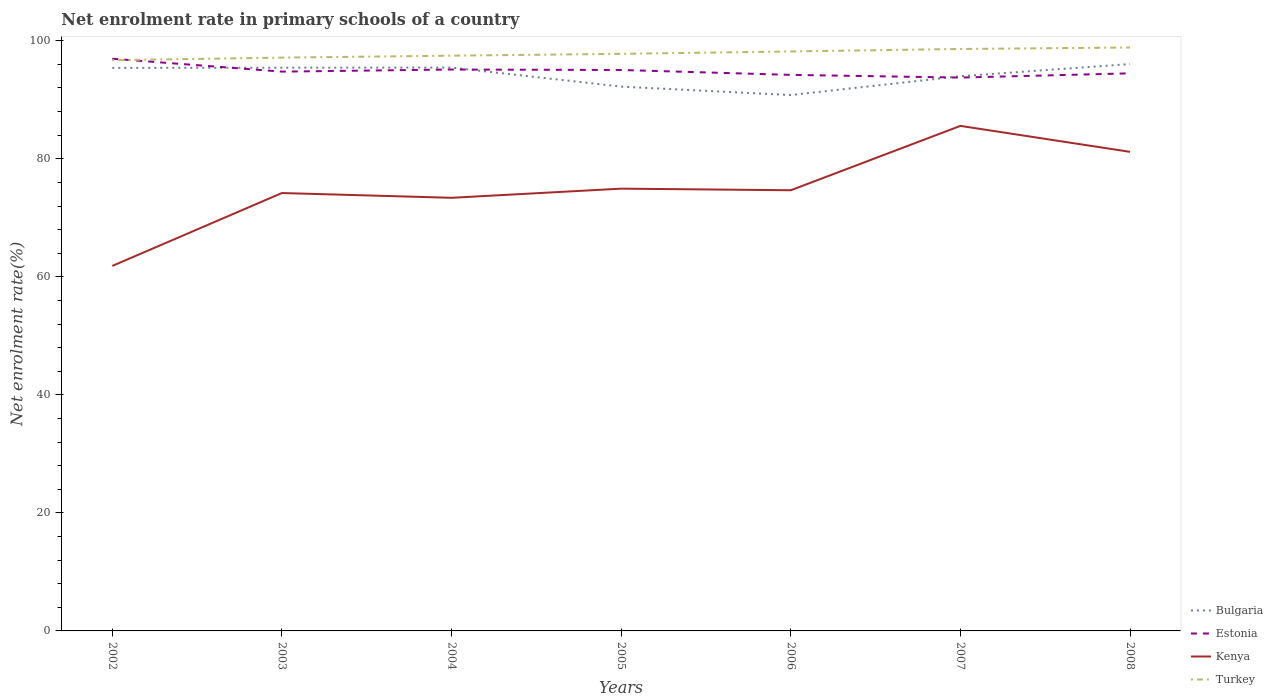How many different coloured lines are there?
Your answer should be compact. 4. Does the line corresponding to Kenya intersect with the line corresponding to Estonia?
Your response must be concise. No. Across all years, what is the maximum net enrolment rate in primary schools in Estonia?
Your response must be concise. 93.77. In which year was the net enrolment rate in primary schools in Kenya maximum?
Offer a very short reply. 2002. What is the total net enrolment rate in primary schools in Bulgaria in the graph?
Give a very brief answer. 1.41. What is the difference between the highest and the second highest net enrolment rate in primary schools in Kenya?
Your answer should be compact. 23.73. Is the net enrolment rate in primary schools in Bulgaria strictly greater than the net enrolment rate in primary schools in Estonia over the years?
Make the answer very short. No. How many lines are there?
Make the answer very short. 4. What is the difference between two consecutive major ticks on the Y-axis?
Provide a succinct answer. 20. Does the graph contain any zero values?
Make the answer very short. No. What is the title of the graph?
Your response must be concise. Net enrolment rate in primary schools of a country. Does "Virgin Islands" appear as one of the legend labels in the graph?
Give a very brief answer. No. What is the label or title of the Y-axis?
Keep it short and to the point. Net enrolment rate(%). What is the Net enrolment rate(%) of Bulgaria in 2002?
Your answer should be compact. 95.41. What is the Net enrolment rate(%) of Estonia in 2002?
Offer a terse response. 96.96. What is the Net enrolment rate(%) in Kenya in 2002?
Your answer should be very brief. 61.85. What is the Net enrolment rate(%) of Turkey in 2002?
Keep it short and to the point. 96.71. What is the Net enrolment rate(%) in Bulgaria in 2003?
Your response must be concise. 95.44. What is the Net enrolment rate(%) of Estonia in 2003?
Give a very brief answer. 94.77. What is the Net enrolment rate(%) of Kenya in 2003?
Offer a very short reply. 74.2. What is the Net enrolment rate(%) of Turkey in 2003?
Offer a terse response. 97.15. What is the Net enrolment rate(%) of Bulgaria in 2004?
Provide a succinct answer. 95.46. What is the Net enrolment rate(%) in Estonia in 2004?
Ensure brevity in your answer.  95.13. What is the Net enrolment rate(%) of Kenya in 2004?
Provide a succinct answer. 73.39. What is the Net enrolment rate(%) in Turkey in 2004?
Your answer should be very brief. 97.48. What is the Net enrolment rate(%) in Bulgaria in 2005?
Offer a terse response. 92.23. What is the Net enrolment rate(%) in Estonia in 2005?
Your answer should be very brief. 95.05. What is the Net enrolment rate(%) in Kenya in 2005?
Provide a short and direct response. 74.94. What is the Net enrolment rate(%) in Turkey in 2005?
Provide a short and direct response. 97.79. What is the Net enrolment rate(%) in Bulgaria in 2006?
Provide a short and direct response. 90.8. What is the Net enrolment rate(%) in Estonia in 2006?
Keep it short and to the point. 94.22. What is the Net enrolment rate(%) of Kenya in 2006?
Keep it short and to the point. 74.67. What is the Net enrolment rate(%) in Turkey in 2006?
Offer a terse response. 98.19. What is the Net enrolment rate(%) in Bulgaria in 2007?
Make the answer very short. 94. What is the Net enrolment rate(%) in Estonia in 2007?
Your answer should be very brief. 93.77. What is the Net enrolment rate(%) of Kenya in 2007?
Your answer should be compact. 85.58. What is the Net enrolment rate(%) in Turkey in 2007?
Ensure brevity in your answer.  98.61. What is the Net enrolment rate(%) of Bulgaria in 2008?
Provide a short and direct response. 96.05. What is the Net enrolment rate(%) in Estonia in 2008?
Your answer should be compact. 94.48. What is the Net enrolment rate(%) in Kenya in 2008?
Offer a very short reply. 81.18. What is the Net enrolment rate(%) in Turkey in 2008?
Make the answer very short. 98.86. Across all years, what is the maximum Net enrolment rate(%) of Bulgaria?
Provide a succinct answer. 96.05. Across all years, what is the maximum Net enrolment rate(%) of Estonia?
Your answer should be very brief. 96.96. Across all years, what is the maximum Net enrolment rate(%) in Kenya?
Make the answer very short. 85.58. Across all years, what is the maximum Net enrolment rate(%) in Turkey?
Your response must be concise. 98.86. Across all years, what is the minimum Net enrolment rate(%) in Bulgaria?
Provide a short and direct response. 90.8. Across all years, what is the minimum Net enrolment rate(%) of Estonia?
Your answer should be compact. 93.77. Across all years, what is the minimum Net enrolment rate(%) of Kenya?
Offer a very short reply. 61.85. Across all years, what is the minimum Net enrolment rate(%) of Turkey?
Provide a succinct answer. 96.71. What is the total Net enrolment rate(%) in Bulgaria in the graph?
Ensure brevity in your answer.  659.4. What is the total Net enrolment rate(%) of Estonia in the graph?
Your response must be concise. 664.39. What is the total Net enrolment rate(%) of Kenya in the graph?
Your answer should be compact. 525.82. What is the total Net enrolment rate(%) of Turkey in the graph?
Your response must be concise. 684.78. What is the difference between the Net enrolment rate(%) in Bulgaria in 2002 and that in 2003?
Offer a terse response. -0.03. What is the difference between the Net enrolment rate(%) in Estonia in 2002 and that in 2003?
Keep it short and to the point. 2.18. What is the difference between the Net enrolment rate(%) of Kenya in 2002 and that in 2003?
Keep it short and to the point. -12.35. What is the difference between the Net enrolment rate(%) of Turkey in 2002 and that in 2003?
Offer a terse response. -0.44. What is the difference between the Net enrolment rate(%) in Bulgaria in 2002 and that in 2004?
Provide a succinct answer. -0.06. What is the difference between the Net enrolment rate(%) of Estonia in 2002 and that in 2004?
Offer a very short reply. 1.83. What is the difference between the Net enrolment rate(%) in Kenya in 2002 and that in 2004?
Your answer should be compact. -11.54. What is the difference between the Net enrolment rate(%) in Turkey in 2002 and that in 2004?
Your answer should be very brief. -0.77. What is the difference between the Net enrolment rate(%) in Bulgaria in 2002 and that in 2005?
Offer a terse response. 3.18. What is the difference between the Net enrolment rate(%) of Estonia in 2002 and that in 2005?
Your answer should be compact. 1.91. What is the difference between the Net enrolment rate(%) of Kenya in 2002 and that in 2005?
Your answer should be very brief. -13.1. What is the difference between the Net enrolment rate(%) of Turkey in 2002 and that in 2005?
Offer a very short reply. -1.08. What is the difference between the Net enrolment rate(%) of Bulgaria in 2002 and that in 2006?
Provide a short and direct response. 4.6. What is the difference between the Net enrolment rate(%) in Estonia in 2002 and that in 2006?
Ensure brevity in your answer.  2.74. What is the difference between the Net enrolment rate(%) in Kenya in 2002 and that in 2006?
Ensure brevity in your answer.  -12.82. What is the difference between the Net enrolment rate(%) of Turkey in 2002 and that in 2006?
Your answer should be compact. -1.48. What is the difference between the Net enrolment rate(%) of Bulgaria in 2002 and that in 2007?
Give a very brief answer. 1.41. What is the difference between the Net enrolment rate(%) in Estonia in 2002 and that in 2007?
Give a very brief answer. 3.19. What is the difference between the Net enrolment rate(%) of Kenya in 2002 and that in 2007?
Give a very brief answer. -23.73. What is the difference between the Net enrolment rate(%) in Turkey in 2002 and that in 2007?
Ensure brevity in your answer.  -1.9. What is the difference between the Net enrolment rate(%) in Bulgaria in 2002 and that in 2008?
Keep it short and to the point. -0.65. What is the difference between the Net enrolment rate(%) of Estonia in 2002 and that in 2008?
Keep it short and to the point. 2.47. What is the difference between the Net enrolment rate(%) of Kenya in 2002 and that in 2008?
Offer a very short reply. -19.33. What is the difference between the Net enrolment rate(%) of Turkey in 2002 and that in 2008?
Give a very brief answer. -2.15. What is the difference between the Net enrolment rate(%) in Bulgaria in 2003 and that in 2004?
Keep it short and to the point. -0.03. What is the difference between the Net enrolment rate(%) in Estonia in 2003 and that in 2004?
Your answer should be very brief. -0.36. What is the difference between the Net enrolment rate(%) of Kenya in 2003 and that in 2004?
Your answer should be compact. 0.81. What is the difference between the Net enrolment rate(%) in Turkey in 2003 and that in 2004?
Offer a very short reply. -0.33. What is the difference between the Net enrolment rate(%) in Bulgaria in 2003 and that in 2005?
Offer a very short reply. 3.21. What is the difference between the Net enrolment rate(%) of Estonia in 2003 and that in 2005?
Give a very brief answer. -0.28. What is the difference between the Net enrolment rate(%) in Kenya in 2003 and that in 2005?
Offer a very short reply. -0.74. What is the difference between the Net enrolment rate(%) in Turkey in 2003 and that in 2005?
Your response must be concise. -0.64. What is the difference between the Net enrolment rate(%) in Bulgaria in 2003 and that in 2006?
Offer a terse response. 4.63. What is the difference between the Net enrolment rate(%) of Estonia in 2003 and that in 2006?
Your response must be concise. 0.55. What is the difference between the Net enrolment rate(%) of Kenya in 2003 and that in 2006?
Give a very brief answer. -0.47. What is the difference between the Net enrolment rate(%) of Turkey in 2003 and that in 2006?
Your response must be concise. -1.04. What is the difference between the Net enrolment rate(%) in Bulgaria in 2003 and that in 2007?
Your answer should be compact. 1.44. What is the difference between the Net enrolment rate(%) in Estonia in 2003 and that in 2007?
Your response must be concise. 1.01. What is the difference between the Net enrolment rate(%) of Kenya in 2003 and that in 2007?
Keep it short and to the point. -11.38. What is the difference between the Net enrolment rate(%) of Turkey in 2003 and that in 2007?
Make the answer very short. -1.46. What is the difference between the Net enrolment rate(%) in Bulgaria in 2003 and that in 2008?
Keep it short and to the point. -0.62. What is the difference between the Net enrolment rate(%) of Estonia in 2003 and that in 2008?
Offer a terse response. 0.29. What is the difference between the Net enrolment rate(%) in Kenya in 2003 and that in 2008?
Provide a succinct answer. -6.98. What is the difference between the Net enrolment rate(%) of Turkey in 2003 and that in 2008?
Give a very brief answer. -1.71. What is the difference between the Net enrolment rate(%) of Bulgaria in 2004 and that in 2005?
Provide a short and direct response. 3.23. What is the difference between the Net enrolment rate(%) of Estonia in 2004 and that in 2005?
Provide a succinct answer. 0.08. What is the difference between the Net enrolment rate(%) in Kenya in 2004 and that in 2005?
Your answer should be compact. -1.55. What is the difference between the Net enrolment rate(%) of Turkey in 2004 and that in 2005?
Provide a succinct answer. -0.31. What is the difference between the Net enrolment rate(%) in Bulgaria in 2004 and that in 2006?
Your response must be concise. 4.66. What is the difference between the Net enrolment rate(%) in Estonia in 2004 and that in 2006?
Your response must be concise. 0.91. What is the difference between the Net enrolment rate(%) in Kenya in 2004 and that in 2006?
Offer a terse response. -1.28. What is the difference between the Net enrolment rate(%) in Turkey in 2004 and that in 2006?
Keep it short and to the point. -0.72. What is the difference between the Net enrolment rate(%) of Bulgaria in 2004 and that in 2007?
Provide a succinct answer. 1.47. What is the difference between the Net enrolment rate(%) in Estonia in 2004 and that in 2007?
Your answer should be very brief. 1.36. What is the difference between the Net enrolment rate(%) of Kenya in 2004 and that in 2007?
Make the answer very short. -12.19. What is the difference between the Net enrolment rate(%) of Turkey in 2004 and that in 2007?
Your response must be concise. -1.14. What is the difference between the Net enrolment rate(%) of Bulgaria in 2004 and that in 2008?
Keep it short and to the point. -0.59. What is the difference between the Net enrolment rate(%) of Estonia in 2004 and that in 2008?
Provide a succinct answer. 0.65. What is the difference between the Net enrolment rate(%) in Kenya in 2004 and that in 2008?
Keep it short and to the point. -7.79. What is the difference between the Net enrolment rate(%) in Turkey in 2004 and that in 2008?
Keep it short and to the point. -1.39. What is the difference between the Net enrolment rate(%) of Bulgaria in 2005 and that in 2006?
Provide a short and direct response. 1.43. What is the difference between the Net enrolment rate(%) of Estonia in 2005 and that in 2006?
Ensure brevity in your answer.  0.83. What is the difference between the Net enrolment rate(%) in Kenya in 2005 and that in 2006?
Make the answer very short. 0.27. What is the difference between the Net enrolment rate(%) of Turkey in 2005 and that in 2006?
Ensure brevity in your answer.  -0.4. What is the difference between the Net enrolment rate(%) of Bulgaria in 2005 and that in 2007?
Provide a succinct answer. -1.77. What is the difference between the Net enrolment rate(%) in Estonia in 2005 and that in 2007?
Provide a short and direct response. 1.29. What is the difference between the Net enrolment rate(%) in Kenya in 2005 and that in 2007?
Ensure brevity in your answer.  -10.63. What is the difference between the Net enrolment rate(%) of Turkey in 2005 and that in 2007?
Offer a terse response. -0.82. What is the difference between the Net enrolment rate(%) of Bulgaria in 2005 and that in 2008?
Offer a terse response. -3.83. What is the difference between the Net enrolment rate(%) of Estonia in 2005 and that in 2008?
Your answer should be compact. 0.57. What is the difference between the Net enrolment rate(%) of Kenya in 2005 and that in 2008?
Your answer should be compact. -6.24. What is the difference between the Net enrolment rate(%) of Turkey in 2005 and that in 2008?
Your answer should be compact. -1.07. What is the difference between the Net enrolment rate(%) in Bulgaria in 2006 and that in 2007?
Your response must be concise. -3.19. What is the difference between the Net enrolment rate(%) of Estonia in 2006 and that in 2007?
Provide a succinct answer. 0.46. What is the difference between the Net enrolment rate(%) in Kenya in 2006 and that in 2007?
Provide a short and direct response. -10.91. What is the difference between the Net enrolment rate(%) of Turkey in 2006 and that in 2007?
Give a very brief answer. -0.42. What is the difference between the Net enrolment rate(%) of Bulgaria in 2006 and that in 2008?
Make the answer very short. -5.25. What is the difference between the Net enrolment rate(%) of Estonia in 2006 and that in 2008?
Your answer should be compact. -0.26. What is the difference between the Net enrolment rate(%) of Kenya in 2006 and that in 2008?
Offer a terse response. -6.51. What is the difference between the Net enrolment rate(%) of Turkey in 2006 and that in 2008?
Your response must be concise. -0.67. What is the difference between the Net enrolment rate(%) of Bulgaria in 2007 and that in 2008?
Provide a succinct answer. -2.06. What is the difference between the Net enrolment rate(%) of Estonia in 2007 and that in 2008?
Ensure brevity in your answer.  -0.72. What is the difference between the Net enrolment rate(%) of Kenya in 2007 and that in 2008?
Your answer should be very brief. 4.4. What is the difference between the Net enrolment rate(%) in Turkey in 2007 and that in 2008?
Give a very brief answer. -0.25. What is the difference between the Net enrolment rate(%) in Bulgaria in 2002 and the Net enrolment rate(%) in Estonia in 2003?
Give a very brief answer. 0.63. What is the difference between the Net enrolment rate(%) of Bulgaria in 2002 and the Net enrolment rate(%) of Kenya in 2003?
Your answer should be very brief. 21.21. What is the difference between the Net enrolment rate(%) of Bulgaria in 2002 and the Net enrolment rate(%) of Turkey in 2003?
Give a very brief answer. -1.74. What is the difference between the Net enrolment rate(%) in Estonia in 2002 and the Net enrolment rate(%) in Kenya in 2003?
Ensure brevity in your answer.  22.76. What is the difference between the Net enrolment rate(%) of Estonia in 2002 and the Net enrolment rate(%) of Turkey in 2003?
Keep it short and to the point. -0.19. What is the difference between the Net enrolment rate(%) in Kenya in 2002 and the Net enrolment rate(%) in Turkey in 2003?
Your answer should be compact. -35.3. What is the difference between the Net enrolment rate(%) of Bulgaria in 2002 and the Net enrolment rate(%) of Estonia in 2004?
Your answer should be compact. 0.28. What is the difference between the Net enrolment rate(%) of Bulgaria in 2002 and the Net enrolment rate(%) of Kenya in 2004?
Your answer should be very brief. 22.02. What is the difference between the Net enrolment rate(%) in Bulgaria in 2002 and the Net enrolment rate(%) in Turkey in 2004?
Your answer should be very brief. -2.07. What is the difference between the Net enrolment rate(%) in Estonia in 2002 and the Net enrolment rate(%) in Kenya in 2004?
Your response must be concise. 23.57. What is the difference between the Net enrolment rate(%) in Estonia in 2002 and the Net enrolment rate(%) in Turkey in 2004?
Your answer should be very brief. -0.52. What is the difference between the Net enrolment rate(%) in Kenya in 2002 and the Net enrolment rate(%) in Turkey in 2004?
Offer a terse response. -35.63. What is the difference between the Net enrolment rate(%) in Bulgaria in 2002 and the Net enrolment rate(%) in Estonia in 2005?
Provide a succinct answer. 0.36. What is the difference between the Net enrolment rate(%) in Bulgaria in 2002 and the Net enrolment rate(%) in Kenya in 2005?
Provide a short and direct response. 20.46. What is the difference between the Net enrolment rate(%) in Bulgaria in 2002 and the Net enrolment rate(%) in Turkey in 2005?
Ensure brevity in your answer.  -2.38. What is the difference between the Net enrolment rate(%) in Estonia in 2002 and the Net enrolment rate(%) in Kenya in 2005?
Make the answer very short. 22.01. What is the difference between the Net enrolment rate(%) in Estonia in 2002 and the Net enrolment rate(%) in Turkey in 2005?
Your answer should be compact. -0.83. What is the difference between the Net enrolment rate(%) in Kenya in 2002 and the Net enrolment rate(%) in Turkey in 2005?
Your answer should be compact. -35.94. What is the difference between the Net enrolment rate(%) in Bulgaria in 2002 and the Net enrolment rate(%) in Estonia in 2006?
Provide a succinct answer. 1.19. What is the difference between the Net enrolment rate(%) in Bulgaria in 2002 and the Net enrolment rate(%) in Kenya in 2006?
Offer a very short reply. 20.74. What is the difference between the Net enrolment rate(%) in Bulgaria in 2002 and the Net enrolment rate(%) in Turkey in 2006?
Keep it short and to the point. -2.78. What is the difference between the Net enrolment rate(%) of Estonia in 2002 and the Net enrolment rate(%) of Kenya in 2006?
Make the answer very short. 22.29. What is the difference between the Net enrolment rate(%) of Estonia in 2002 and the Net enrolment rate(%) of Turkey in 2006?
Ensure brevity in your answer.  -1.23. What is the difference between the Net enrolment rate(%) of Kenya in 2002 and the Net enrolment rate(%) of Turkey in 2006?
Provide a short and direct response. -36.34. What is the difference between the Net enrolment rate(%) in Bulgaria in 2002 and the Net enrolment rate(%) in Estonia in 2007?
Your response must be concise. 1.64. What is the difference between the Net enrolment rate(%) of Bulgaria in 2002 and the Net enrolment rate(%) of Kenya in 2007?
Your answer should be compact. 9.83. What is the difference between the Net enrolment rate(%) in Bulgaria in 2002 and the Net enrolment rate(%) in Turkey in 2007?
Your answer should be compact. -3.2. What is the difference between the Net enrolment rate(%) in Estonia in 2002 and the Net enrolment rate(%) in Kenya in 2007?
Your answer should be compact. 11.38. What is the difference between the Net enrolment rate(%) of Estonia in 2002 and the Net enrolment rate(%) of Turkey in 2007?
Your answer should be very brief. -1.65. What is the difference between the Net enrolment rate(%) in Kenya in 2002 and the Net enrolment rate(%) in Turkey in 2007?
Your answer should be compact. -36.76. What is the difference between the Net enrolment rate(%) in Bulgaria in 2002 and the Net enrolment rate(%) in Estonia in 2008?
Give a very brief answer. 0.92. What is the difference between the Net enrolment rate(%) of Bulgaria in 2002 and the Net enrolment rate(%) of Kenya in 2008?
Your answer should be very brief. 14.23. What is the difference between the Net enrolment rate(%) in Bulgaria in 2002 and the Net enrolment rate(%) in Turkey in 2008?
Make the answer very short. -3.45. What is the difference between the Net enrolment rate(%) of Estonia in 2002 and the Net enrolment rate(%) of Kenya in 2008?
Your answer should be compact. 15.78. What is the difference between the Net enrolment rate(%) in Estonia in 2002 and the Net enrolment rate(%) in Turkey in 2008?
Give a very brief answer. -1.9. What is the difference between the Net enrolment rate(%) of Kenya in 2002 and the Net enrolment rate(%) of Turkey in 2008?
Your response must be concise. -37.01. What is the difference between the Net enrolment rate(%) of Bulgaria in 2003 and the Net enrolment rate(%) of Estonia in 2004?
Ensure brevity in your answer.  0.31. What is the difference between the Net enrolment rate(%) of Bulgaria in 2003 and the Net enrolment rate(%) of Kenya in 2004?
Your response must be concise. 22.05. What is the difference between the Net enrolment rate(%) of Bulgaria in 2003 and the Net enrolment rate(%) of Turkey in 2004?
Your response must be concise. -2.04. What is the difference between the Net enrolment rate(%) in Estonia in 2003 and the Net enrolment rate(%) in Kenya in 2004?
Ensure brevity in your answer.  21.38. What is the difference between the Net enrolment rate(%) in Estonia in 2003 and the Net enrolment rate(%) in Turkey in 2004?
Your answer should be very brief. -2.7. What is the difference between the Net enrolment rate(%) in Kenya in 2003 and the Net enrolment rate(%) in Turkey in 2004?
Make the answer very short. -23.27. What is the difference between the Net enrolment rate(%) of Bulgaria in 2003 and the Net enrolment rate(%) of Estonia in 2005?
Give a very brief answer. 0.39. What is the difference between the Net enrolment rate(%) of Bulgaria in 2003 and the Net enrolment rate(%) of Kenya in 2005?
Make the answer very short. 20.49. What is the difference between the Net enrolment rate(%) of Bulgaria in 2003 and the Net enrolment rate(%) of Turkey in 2005?
Your response must be concise. -2.35. What is the difference between the Net enrolment rate(%) in Estonia in 2003 and the Net enrolment rate(%) in Kenya in 2005?
Give a very brief answer. 19.83. What is the difference between the Net enrolment rate(%) in Estonia in 2003 and the Net enrolment rate(%) in Turkey in 2005?
Provide a short and direct response. -3.01. What is the difference between the Net enrolment rate(%) in Kenya in 2003 and the Net enrolment rate(%) in Turkey in 2005?
Make the answer very short. -23.59. What is the difference between the Net enrolment rate(%) in Bulgaria in 2003 and the Net enrolment rate(%) in Estonia in 2006?
Keep it short and to the point. 1.22. What is the difference between the Net enrolment rate(%) of Bulgaria in 2003 and the Net enrolment rate(%) of Kenya in 2006?
Provide a short and direct response. 20.77. What is the difference between the Net enrolment rate(%) in Bulgaria in 2003 and the Net enrolment rate(%) in Turkey in 2006?
Your answer should be compact. -2.75. What is the difference between the Net enrolment rate(%) of Estonia in 2003 and the Net enrolment rate(%) of Kenya in 2006?
Provide a short and direct response. 20.1. What is the difference between the Net enrolment rate(%) in Estonia in 2003 and the Net enrolment rate(%) in Turkey in 2006?
Ensure brevity in your answer.  -3.42. What is the difference between the Net enrolment rate(%) of Kenya in 2003 and the Net enrolment rate(%) of Turkey in 2006?
Give a very brief answer. -23.99. What is the difference between the Net enrolment rate(%) in Bulgaria in 2003 and the Net enrolment rate(%) in Estonia in 2007?
Keep it short and to the point. 1.67. What is the difference between the Net enrolment rate(%) in Bulgaria in 2003 and the Net enrolment rate(%) in Kenya in 2007?
Provide a succinct answer. 9.86. What is the difference between the Net enrolment rate(%) in Bulgaria in 2003 and the Net enrolment rate(%) in Turkey in 2007?
Your answer should be compact. -3.17. What is the difference between the Net enrolment rate(%) in Estonia in 2003 and the Net enrolment rate(%) in Kenya in 2007?
Provide a short and direct response. 9.2. What is the difference between the Net enrolment rate(%) in Estonia in 2003 and the Net enrolment rate(%) in Turkey in 2007?
Make the answer very short. -3.84. What is the difference between the Net enrolment rate(%) in Kenya in 2003 and the Net enrolment rate(%) in Turkey in 2007?
Provide a succinct answer. -24.41. What is the difference between the Net enrolment rate(%) in Bulgaria in 2003 and the Net enrolment rate(%) in Estonia in 2008?
Give a very brief answer. 0.95. What is the difference between the Net enrolment rate(%) in Bulgaria in 2003 and the Net enrolment rate(%) in Kenya in 2008?
Give a very brief answer. 14.26. What is the difference between the Net enrolment rate(%) of Bulgaria in 2003 and the Net enrolment rate(%) of Turkey in 2008?
Your response must be concise. -3.42. What is the difference between the Net enrolment rate(%) of Estonia in 2003 and the Net enrolment rate(%) of Kenya in 2008?
Offer a very short reply. 13.59. What is the difference between the Net enrolment rate(%) in Estonia in 2003 and the Net enrolment rate(%) in Turkey in 2008?
Make the answer very short. -4.09. What is the difference between the Net enrolment rate(%) of Kenya in 2003 and the Net enrolment rate(%) of Turkey in 2008?
Your answer should be very brief. -24.66. What is the difference between the Net enrolment rate(%) of Bulgaria in 2004 and the Net enrolment rate(%) of Estonia in 2005?
Make the answer very short. 0.41. What is the difference between the Net enrolment rate(%) in Bulgaria in 2004 and the Net enrolment rate(%) in Kenya in 2005?
Your answer should be very brief. 20.52. What is the difference between the Net enrolment rate(%) of Bulgaria in 2004 and the Net enrolment rate(%) of Turkey in 2005?
Ensure brevity in your answer.  -2.32. What is the difference between the Net enrolment rate(%) in Estonia in 2004 and the Net enrolment rate(%) in Kenya in 2005?
Offer a very short reply. 20.19. What is the difference between the Net enrolment rate(%) of Estonia in 2004 and the Net enrolment rate(%) of Turkey in 2005?
Provide a succinct answer. -2.66. What is the difference between the Net enrolment rate(%) in Kenya in 2004 and the Net enrolment rate(%) in Turkey in 2005?
Keep it short and to the point. -24.4. What is the difference between the Net enrolment rate(%) in Bulgaria in 2004 and the Net enrolment rate(%) in Estonia in 2006?
Offer a terse response. 1.24. What is the difference between the Net enrolment rate(%) of Bulgaria in 2004 and the Net enrolment rate(%) of Kenya in 2006?
Provide a short and direct response. 20.79. What is the difference between the Net enrolment rate(%) of Bulgaria in 2004 and the Net enrolment rate(%) of Turkey in 2006?
Provide a short and direct response. -2.73. What is the difference between the Net enrolment rate(%) in Estonia in 2004 and the Net enrolment rate(%) in Kenya in 2006?
Ensure brevity in your answer.  20.46. What is the difference between the Net enrolment rate(%) of Estonia in 2004 and the Net enrolment rate(%) of Turkey in 2006?
Ensure brevity in your answer.  -3.06. What is the difference between the Net enrolment rate(%) of Kenya in 2004 and the Net enrolment rate(%) of Turkey in 2006?
Make the answer very short. -24.8. What is the difference between the Net enrolment rate(%) of Bulgaria in 2004 and the Net enrolment rate(%) of Estonia in 2007?
Make the answer very short. 1.7. What is the difference between the Net enrolment rate(%) in Bulgaria in 2004 and the Net enrolment rate(%) in Kenya in 2007?
Your answer should be compact. 9.89. What is the difference between the Net enrolment rate(%) of Bulgaria in 2004 and the Net enrolment rate(%) of Turkey in 2007?
Ensure brevity in your answer.  -3.15. What is the difference between the Net enrolment rate(%) of Estonia in 2004 and the Net enrolment rate(%) of Kenya in 2007?
Offer a very short reply. 9.55. What is the difference between the Net enrolment rate(%) in Estonia in 2004 and the Net enrolment rate(%) in Turkey in 2007?
Your answer should be compact. -3.48. What is the difference between the Net enrolment rate(%) of Kenya in 2004 and the Net enrolment rate(%) of Turkey in 2007?
Offer a very short reply. -25.22. What is the difference between the Net enrolment rate(%) of Bulgaria in 2004 and the Net enrolment rate(%) of Estonia in 2008?
Give a very brief answer. 0.98. What is the difference between the Net enrolment rate(%) of Bulgaria in 2004 and the Net enrolment rate(%) of Kenya in 2008?
Your answer should be compact. 14.28. What is the difference between the Net enrolment rate(%) in Bulgaria in 2004 and the Net enrolment rate(%) in Turkey in 2008?
Ensure brevity in your answer.  -3.4. What is the difference between the Net enrolment rate(%) in Estonia in 2004 and the Net enrolment rate(%) in Kenya in 2008?
Ensure brevity in your answer.  13.95. What is the difference between the Net enrolment rate(%) of Estonia in 2004 and the Net enrolment rate(%) of Turkey in 2008?
Provide a short and direct response. -3.73. What is the difference between the Net enrolment rate(%) in Kenya in 2004 and the Net enrolment rate(%) in Turkey in 2008?
Offer a very short reply. -25.47. What is the difference between the Net enrolment rate(%) in Bulgaria in 2005 and the Net enrolment rate(%) in Estonia in 2006?
Your response must be concise. -1.99. What is the difference between the Net enrolment rate(%) in Bulgaria in 2005 and the Net enrolment rate(%) in Kenya in 2006?
Provide a succinct answer. 17.56. What is the difference between the Net enrolment rate(%) in Bulgaria in 2005 and the Net enrolment rate(%) in Turkey in 2006?
Offer a terse response. -5.96. What is the difference between the Net enrolment rate(%) of Estonia in 2005 and the Net enrolment rate(%) of Kenya in 2006?
Ensure brevity in your answer.  20.38. What is the difference between the Net enrolment rate(%) of Estonia in 2005 and the Net enrolment rate(%) of Turkey in 2006?
Ensure brevity in your answer.  -3.14. What is the difference between the Net enrolment rate(%) of Kenya in 2005 and the Net enrolment rate(%) of Turkey in 2006?
Give a very brief answer. -23.25. What is the difference between the Net enrolment rate(%) of Bulgaria in 2005 and the Net enrolment rate(%) of Estonia in 2007?
Provide a succinct answer. -1.54. What is the difference between the Net enrolment rate(%) of Bulgaria in 2005 and the Net enrolment rate(%) of Kenya in 2007?
Your response must be concise. 6.65. What is the difference between the Net enrolment rate(%) in Bulgaria in 2005 and the Net enrolment rate(%) in Turkey in 2007?
Offer a terse response. -6.38. What is the difference between the Net enrolment rate(%) in Estonia in 2005 and the Net enrolment rate(%) in Kenya in 2007?
Make the answer very short. 9.47. What is the difference between the Net enrolment rate(%) in Estonia in 2005 and the Net enrolment rate(%) in Turkey in 2007?
Your response must be concise. -3.56. What is the difference between the Net enrolment rate(%) of Kenya in 2005 and the Net enrolment rate(%) of Turkey in 2007?
Your answer should be very brief. -23.67. What is the difference between the Net enrolment rate(%) of Bulgaria in 2005 and the Net enrolment rate(%) of Estonia in 2008?
Keep it short and to the point. -2.26. What is the difference between the Net enrolment rate(%) of Bulgaria in 2005 and the Net enrolment rate(%) of Kenya in 2008?
Your answer should be very brief. 11.05. What is the difference between the Net enrolment rate(%) in Bulgaria in 2005 and the Net enrolment rate(%) in Turkey in 2008?
Offer a very short reply. -6.63. What is the difference between the Net enrolment rate(%) in Estonia in 2005 and the Net enrolment rate(%) in Kenya in 2008?
Provide a short and direct response. 13.87. What is the difference between the Net enrolment rate(%) of Estonia in 2005 and the Net enrolment rate(%) of Turkey in 2008?
Your answer should be compact. -3.81. What is the difference between the Net enrolment rate(%) in Kenya in 2005 and the Net enrolment rate(%) in Turkey in 2008?
Your response must be concise. -23.92. What is the difference between the Net enrolment rate(%) in Bulgaria in 2006 and the Net enrolment rate(%) in Estonia in 2007?
Make the answer very short. -2.96. What is the difference between the Net enrolment rate(%) in Bulgaria in 2006 and the Net enrolment rate(%) in Kenya in 2007?
Make the answer very short. 5.23. What is the difference between the Net enrolment rate(%) of Bulgaria in 2006 and the Net enrolment rate(%) of Turkey in 2007?
Make the answer very short. -7.81. What is the difference between the Net enrolment rate(%) of Estonia in 2006 and the Net enrolment rate(%) of Kenya in 2007?
Offer a very short reply. 8.64. What is the difference between the Net enrolment rate(%) of Estonia in 2006 and the Net enrolment rate(%) of Turkey in 2007?
Offer a very short reply. -4.39. What is the difference between the Net enrolment rate(%) in Kenya in 2006 and the Net enrolment rate(%) in Turkey in 2007?
Your answer should be compact. -23.94. What is the difference between the Net enrolment rate(%) of Bulgaria in 2006 and the Net enrolment rate(%) of Estonia in 2008?
Ensure brevity in your answer.  -3.68. What is the difference between the Net enrolment rate(%) in Bulgaria in 2006 and the Net enrolment rate(%) in Kenya in 2008?
Offer a terse response. 9.62. What is the difference between the Net enrolment rate(%) in Bulgaria in 2006 and the Net enrolment rate(%) in Turkey in 2008?
Give a very brief answer. -8.06. What is the difference between the Net enrolment rate(%) in Estonia in 2006 and the Net enrolment rate(%) in Kenya in 2008?
Make the answer very short. 13.04. What is the difference between the Net enrolment rate(%) of Estonia in 2006 and the Net enrolment rate(%) of Turkey in 2008?
Your answer should be compact. -4.64. What is the difference between the Net enrolment rate(%) in Kenya in 2006 and the Net enrolment rate(%) in Turkey in 2008?
Make the answer very short. -24.19. What is the difference between the Net enrolment rate(%) in Bulgaria in 2007 and the Net enrolment rate(%) in Estonia in 2008?
Your answer should be compact. -0.49. What is the difference between the Net enrolment rate(%) of Bulgaria in 2007 and the Net enrolment rate(%) of Kenya in 2008?
Ensure brevity in your answer.  12.82. What is the difference between the Net enrolment rate(%) of Bulgaria in 2007 and the Net enrolment rate(%) of Turkey in 2008?
Offer a terse response. -4.86. What is the difference between the Net enrolment rate(%) in Estonia in 2007 and the Net enrolment rate(%) in Kenya in 2008?
Keep it short and to the point. 12.59. What is the difference between the Net enrolment rate(%) in Estonia in 2007 and the Net enrolment rate(%) in Turkey in 2008?
Ensure brevity in your answer.  -5.1. What is the difference between the Net enrolment rate(%) of Kenya in 2007 and the Net enrolment rate(%) of Turkey in 2008?
Make the answer very short. -13.28. What is the average Net enrolment rate(%) in Bulgaria per year?
Provide a short and direct response. 94.2. What is the average Net enrolment rate(%) of Estonia per year?
Offer a very short reply. 94.91. What is the average Net enrolment rate(%) in Kenya per year?
Keep it short and to the point. 75.12. What is the average Net enrolment rate(%) in Turkey per year?
Provide a succinct answer. 97.83. In the year 2002, what is the difference between the Net enrolment rate(%) in Bulgaria and Net enrolment rate(%) in Estonia?
Offer a very short reply. -1.55. In the year 2002, what is the difference between the Net enrolment rate(%) in Bulgaria and Net enrolment rate(%) in Kenya?
Your answer should be very brief. 33.56. In the year 2002, what is the difference between the Net enrolment rate(%) of Bulgaria and Net enrolment rate(%) of Turkey?
Your answer should be very brief. -1.3. In the year 2002, what is the difference between the Net enrolment rate(%) of Estonia and Net enrolment rate(%) of Kenya?
Offer a very short reply. 35.11. In the year 2002, what is the difference between the Net enrolment rate(%) of Estonia and Net enrolment rate(%) of Turkey?
Your answer should be very brief. 0.25. In the year 2002, what is the difference between the Net enrolment rate(%) in Kenya and Net enrolment rate(%) in Turkey?
Give a very brief answer. -34.86. In the year 2003, what is the difference between the Net enrolment rate(%) in Bulgaria and Net enrolment rate(%) in Estonia?
Offer a very short reply. 0.66. In the year 2003, what is the difference between the Net enrolment rate(%) in Bulgaria and Net enrolment rate(%) in Kenya?
Keep it short and to the point. 21.24. In the year 2003, what is the difference between the Net enrolment rate(%) of Bulgaria and Net enrolment rate(%) of Turkey?
Provide a succinct answer. -1.71. In the year 2003, what is the difference between the Net enrolment rate(%) in Estonia and Net enrolment rate(%) in Kenya?
Give a very brief answer. 20.57. In the year 2003, what is the difference between the Net enrolment rate(%) of Estonia and Net enrolment rate(%) of Turkey?
Your response must be concise. -2.37. In the year 2003, what is the difference between the Net enrolment rate(%) of Kenya and Net enrolment rate(%) of Turkey?
Offer a terse response. -22.95. In the year 2004, what is the difference between the Net enrolment rate(%) of Bulgaria and Net enrolment rate(%) of Estonia?
Provide a short and direct response. 0.33. In the year 2004, what is the difference between the Net enrolment rate(%) of Bulgaria and Net enrolment rate(%) of Kenya?
Your response must be concise. 22.07. In the year 2004, what is the difference between the Net enrolment rate(%) of Bulgaria and Net enrolment rate(%) of Turkey?
Provide a succinct answer. -2.01. In the year 2004, what is the difference between the Net enrolment rate(%) in Estonia and Net enrolment rate(%) in Kenya?
Ensure brevity in your answer.  21.74. In the year 2004, what is the difference between the Net enrolment rate(%) in Estonia and Net enrolment rate(%) in Turkey?
Offer a terse response. -2.34. In the year 2004, what is the difference between the Net enrolment rate(%) of Kenya and Net enrolment rate(%) of Turkey?
Give a very brief answer. -24.08. In the year 2005, what is the difference between the Net enrolment rate(%) in Bulgaria and Net enrolment rate(%) in Estonia?
Your answer should be compact. -2.82. In the year 2005, what is the difference between the Net enrolment rate(%) of Bulgaria and Net enrolment rate(%) of Kenya?
Offer a terse response. 17.29. In the year 2005, what is the difference between the Net enrolment rate(%) in Bulgaria and Net enrolment rate(%) in Turkey?
Ensure brevity in your answer.  -5.56. In the year 2005, what is the difference between the Net enrolment rate(%) in Estonia and Net enrolment rate(%) in Kenya?
Give a very brief answer. 20.11. In the year 2005, what is the difference between the Net enrolment rate(%) in Estonia and Net enrolment rate(%) in Turkey?
Offer a terse response. -2.74. In the year 2005, what is the difference between the Net enrolment rate(%) of Kenya and Net enrolment rate(%) of Turkey?
Provide a succinct answer. -22.84. In the year 2006, what is the difference between the Net enrolment rate(%) in Bulgaria and Net enrolment rate(%) in Estonia?
Make the answer very short. -3.42. In the year 2006, what is the difference between the Net enrolment rate(%) of Bulgaria and Net enrolment rate(%) of Kenya?
Your response must be concise. 16.13. In the year 2006, what is the difference between the Net enrolment rate(%) in Bulgaria and Net enrolment rate(%) in Turkey?
Keep it short and to the point. -7.39. In the year 2006, what is the difference between the Net enrolment rate(%) in Estonia and Net enrolment rate(%) in Kenya?
Make the answer very short. 19.55. In the year 2006, what is the difference between the Net enrolment rate(%) in Estonia and Net enrolment rate(%) in Turkey?
Ensure brevity in your answer.  -3.97. In the year 2006, what is the difference between the Net enrolment rate(%) of Kenya and Net enrolment rate(%) of Turkey?
Provide a short and direct response. -23.52. In the year 2007, what is the difference between the Net enrolment rate(%) of Bulgaria and Net enrolment rate(%) of Estonia?
Ensure brevity in your answer.  0.23. In the year 2007, what is the difference between the Net enrolment rate(%) of Bulgaria and Net enrolment rate(%) of Kenya?
Give a very brief answer. 8.42. In the year 2007, what is the difference between the Net enrolment rate(%) in Bulgaria and Net enrolment rate(%) in Turkey?
Keep it short and to the point. -4.61. In the year 2007, what is the difference between the Net enrolment rate(%) in Estonia and Net enrolment rate(%) in Kenya?
Offer a terse response. 8.19. In the year 2007, what is the difference between the Net enrolment rate(%) of Estonia and Net enrolment rate(%) of Turkey?
Offer a very short reply. -4.84. In the year 2007, what is the difference between the Net enrolment rate(%) in Kenya and Net enrolment rate(%) in Turkey?
Your response must be concise. -13.03. In the year 2008, what is the difference between the Net enrolment rate(%) in Bulgaria and Net enrolment rate(%) in Estonia?
Offer a terse response. 1.57. In the year 2008, what is the difference between the Net enrolment rate(%) of Bulgaria and Net enrolment rate(%) of Kenya?
Your answer should be compact. 14.88. In the year 2008, what is the difference between the Net enrolment rate(%) of Bulgaria and Net enrolment rate(%) of Turkey?
Provide a succinct answer. -2.81. In the year 2008, what is the difference between the Net enrolment rate(%) in Estonia and Net enrolment rate(%) in Kenya?
Your answer should be compact. 13.3. In the year 2008, what is the difference between the Net enrolment rate(%) of Estonia and Net enrolment rate(%) of Turkey?
Make the answer very short. -4.38. In the year 2008, what is the difference between the Net enrolment rate(%) in Kenya and Net enrolment rate(%) in Turkey?
Provide a short and direct response. -17.68. What is the ratio of the Net enrolment rate(%) of Bulgaria in 2002 to that in 2003?
Give a very brief answer. 1. What is the ratio of the Net enrolment rate(%) in Kenya in 2002 to that in 2003?
Your answer should be very brief. 0.83. What is the ratio of the Net enrolment rate(%) in Bulgaria in 2002 to that in 2004?
Your response must be concise. 1. What is the ratio of the Net enrolment rate(%) of Estonia in 2002 to that in 2004?
Your answer should be very brief. 1.02. What is the ratio of the Net enrolment rate(%) of Kenya in 2002 to that in 2004?
Your response must be concise. 0.84. What is the ratio of the Net enrolment rate(%) of Turkey in 2002 to that in 2004?
Ensure brevity in your answer.  0.99. What is the ratio of the Net enrolment rate(%) of Bulgaria in 2002 to that in 2005?
Your response must be concise. 1.03. What is the ratio of the Net enrolment rate(%) in Estonia in 2002 to that in 2005?
Your answer should be compact. 1.02. What is the ratio of the Net enrolment rate(%) of Kenya in 2002 to that in 2005?
Your answer should be very brief. 0.83. What is the ratio of the Net enrolment rate(%) in Bulgaria in 2002 to that in 2006?
Offer a very short reply. 1.05. What is the ratio of the Net enrolment rate(%) of Estonia in 2002 to that in 2006?
Keep it short and to the point. 1.03. What is the ratio of the Net enrolment rate(%) of Kenya in 2002 to that in 2006?
Your response must be concise. 0.83. What is the ratio of the Net enrolment rate(%) in Turkey in 2002 to that in 2006?
Provide a short and direct response. 0.98. What is the ratio of the Net enrolment rate(%) in Bulgaria in 2002 to that in 2007?
Keep it short and to the point. 1.01. What is the ratio of the Net enrolment rate(%) in Estonia in 2002 to that in 2007?
Keep it short and to the point. 1.03. What is the ratio of the Net enrolment rate(%) in Kenya in 2002 to that in 2007?
Keep it short and to the point. 0.72. What is the ratio of the Net enrolment rate(%) in Turkey in 2002 to that in 2007?
Offer a very short reply. 0.98. What is the ratio of the Net enrolment rate(%) in Estonia in 2002 to that in 2008?
Provide a succinct answer. 1.03. What is the ratio of the Net enrolment rate(%) of Kenya in 2002 to that in 2008?
Provide a short and direct response. 0.76. What is the ratio of the Net enrolment rate(%) in Turkey in 2002 to that in 2008?
Provide a short and direct response. 0.98. What is the ratio of the Net enrolment rate(%) of Bulgaria in 2003 to that in 2004?
Give a very brief answer. 1. What is the ratio of the Net enrolment rate(%) of Kenya in 2003 to that in 2004?
Your answer should be very brief. 1.01. What is the ratio of the Net enrolment rate(%) of Bulgaria in 2003 to that in 2005?
Offer a terse response. 1.03. What is the ratio of the Net enrolment rate(%) in Bulgaria in 2003 to that in 2006?
Your answer should be very brief. 1.05. What is the ratio of the Net enrolment rate(%) in Estonia in 2003 to that in 2006?
Provide a succinct answer. 1.01. What is the ratio of the Net enrolment rate(%) of Kenya in 2003 to that in 2006?
Give a very brief answer. 0.99. What is the ratio of the Net enrolment rate(%) of Turkey in 2003 to that in 2006?
Keep it short and to the point. 0.99. What is the ratio of the Net enrolment rate(%) in Bulgaria in 2003 to that in 2007?
Your answer should be compact. 1.02. What is the ratio of the Net enrolment rate(%) of Estonia in 2003 to that in 2007?
Your response must be concise. 1.01. What is the ratio of the Net enrolment rate(%) in Kenya in 2003 to that in 2007?
Keep it short and to the point. 0.87. What is the ratio of the Net enrolment rate(%) in Turkey in 2003 to that in 2007?
Ensure brevity in your answer.  0.99. What is the ratio of the Net enrolment rate(%) in Kenya in 2003 to that in 2008?
Your answer should be very brief. 0.91. What is the ratio of the Net enrolment rate(%) in Turkey in 2003 to that in 2008?
Offer a terse response. 0.98. What is the ratio of the Net enrolment rate(%) of Bulgaria in 2004 to that in 2005?
Your answer should be compact. 1.04. What is the ratio of the Net enrolment rate(%) of Kenya in 2004 to that in 2005?
Make the answer very short. 0.98. What is the ratio of the Net enrolment rate(%) of Bulgaria in 2004 to that in 2006?
Give a very brief answer. 1.05. What is the ratio of the Net enrolment rate(%) of Estonia in 2004 to that in 2006?
Provide a succinct answer. 1.01. What is the ratio of the Net enrolment rate(%) of Kenya in 2004 to that in 2006?
Your answer should be very brief. 0.98. What is the ratio of the Net enrolment rate(%) in Turkey in 2004 to that in 2006?
Make the answer very short. 0.99. What is the ratio of the Net enrolment rate(%) in Bulgaria in 2004 to that in 2007?
Keep it short and to the point. 1.02. What is the ratio of the Net enrolment rate(%) of Estonia in 2004 to that in 2007?
Give a very brief answer. 1.01. What is the ratio of the Net enrolment rate(%) in Kenya in 2004 to that in 2007?
Give a very brief answer. 0.86. What is the ratio of the Net enrolment rate(%) in Estonia in 2004 to that in 2008?
Offer a very short reply. 1.01. What is the ratio of the Net enrolment rate(%) of Kenya in 2004 to that in 2008?
Ensure brevity in your answer.  0.9. What is the ratio of the Net enrolment rate(%) of Turkey in 2004 to that in 2008?
Ensure brevity in your answer.  0.99. What is the ratio of the Net enrolment rate(%) in Bulgaria in 2005 to that in 2006?
Provide a short and direct response. 1.02. What is the ratio of the Net enrolment rate(%) in Estonia in 2005 to that in 2006?
Keep it short and to the point. 1.01. What is the ratio of the Net enrolment rate(%) of Kenya in 2005 to that in 2006?
Make the answer very short. 1. What is the ratio of the Net enrolment rate(%) in Bulgaria in 2005 to that in 2007?
Offer a terse response. 0.98. What is the ratio of the Net enrolment rate(%) of Estonia in 2005 to that in 2007?
Make the answer very short. 1.01. What is the ratio of the Net enrolment rate(%) in Kenya in 2005 to that in 2007?
Offer a terse response. 0.88. What is the ratio of the Net enrolment rate(%) in Bulgaria in 2005 to that in 2008?
Give a very brief answer. 0.96. What is the ratio of the Net enrolment rate(%) in Estonia in 2005 to that in 2008?
Give a very brief answer. 1.01. What is the ratio of the Net enrolment rate(%) of Kenya in 2005 to that in 2008?
Offer a very short reply. 0.92. What is the ratio of the Net enrolment rate(%) in Turkey in 2005 to that in 2008?
Your response must be concise. 0.99. What is the ratio of the Net enrolment rate(%) of Estonia in 2006 to that in 2007?
Keep it short and to the point. 1. What is the ratio of the Net enrolment rate(%) in Kenya in 2006 to that in 2007?
Keep it short and to the point. 0.87. What is the ratio of the Net enrolment rate(%) of Turkey in 2006 to that in 2007?
Offer a terse response. 1. What is the ratio of the Net enrolment rate(%) in Bulgaria in 2006 to that in 2008?
Give a very brief answer. 0.95. What is the ratio of the Net enrolment rate(%) in Estonia in 2006 to that in 2008?
Provide a short and direct response. 1. What is the ratio of the Net enrolment rate(%) in Kenya in 2006 to that in 2008?
Provide a succinct answer. 0.92. What is the ratio of the Net enrolment rate(%) of Bulgaria in 2007 to that in 2008?
Offer a very short reply. 0.98. What is the ratio of the Net enrolment rate(%) in Estonia in 2007 to that in 2008?
Your response must be concise. 0.99. What is the ratio of the Net enrolment rate(%) in Kenya in 2007 to that in 2008?
Your answer should be very brief. 1.05. What is the difference between the highest and the second highest Net enrolment rate(%) of Bulgaria?
Your answer should be very brief. 0.59. What is the difference between the highest and the second highest Net enrolment rate(%) of Estonia?
Your response must be concise. 1.83. What is the difference between the highest and the second highest Net enrolment rate(%) in Kenya?
Your response must be concise. 4.4. What is the difference between the highest and the second highest Net enrolment rate(%) of Turkey?
Your response must be concise. 0.25. What is the difference between the highest and the lowest Net enrolment rate(%) of Bulgaria?
Ensure brevity in your answer.  5.25. What is the difference between the highest and the lowest Net enrolment rate(%) of Estonia?
Provide a succinct answer. 3.19. What is the difference between the highest and the lowest Net enrolment rate(%) in Kenya?
Your response must be concise. 23.73. What is the difference between the highest and the lowest Net enrolment rate(%) in Turkey?
Offer a very short reply. 2.15. 